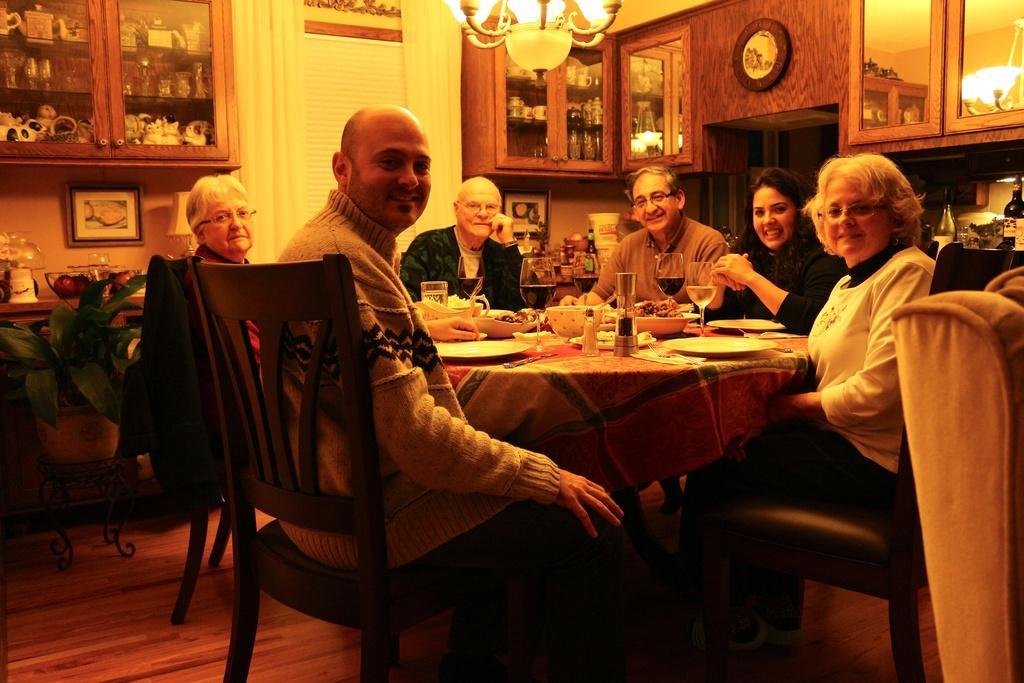Could you give a brief overview of what you see in this image? In this image there are few persons sitting on the chair before at a table. On table there are plates , glasses, bowls which has food. At the left side there is a pot with a plant on stand. At the left top there is a shelf having toys and glasses in it. At the top of the image there is a chandelier. At the left side there are few bottles. 